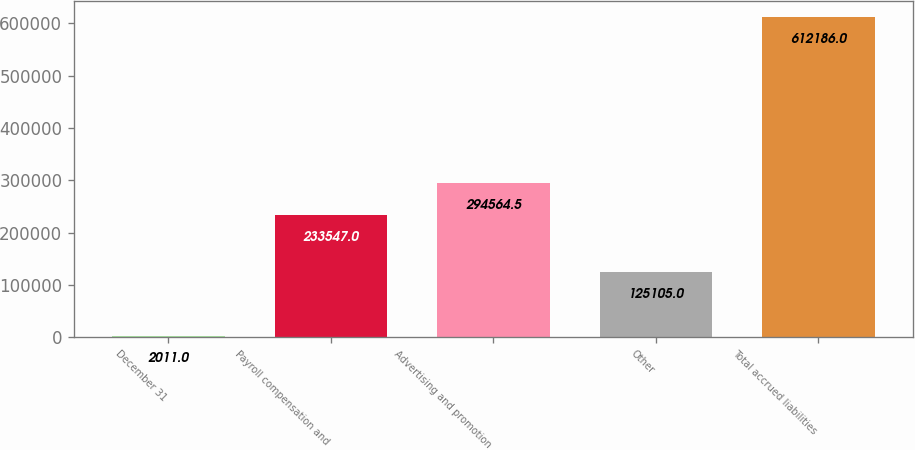Convert chart. <chart><loc_0><loc_0><loc_500><loc_500><bar_chart><fcel>December 31<fcel>Payroll compensation and<fcel>Advertising and promotion<fcel>Other<fcel>Total accrued liabilities<nl><fcel>2011<fcel>233547<fcel>294564<fcel>125105<fcel>612186<nl></chart> 